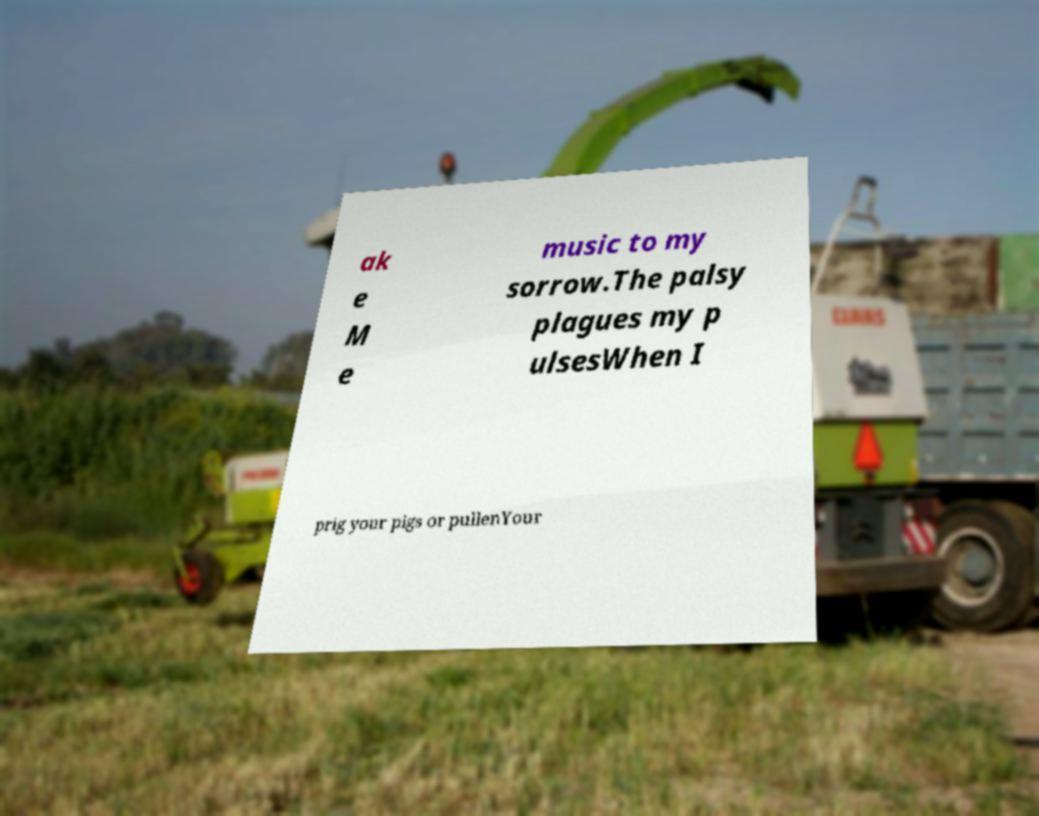Please read and relay the text visible in this image. What does it say? ak e M e music to my sorrow.The palsy plagues my p ulsesWhen I prig your pigs or pullenYour 